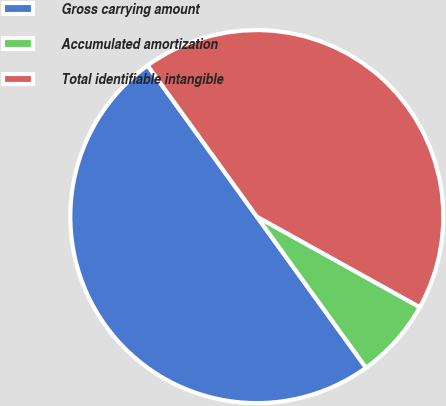Convert chart. <chart><loc_0><loc_0><loc_500><loc_500><pie_chart><fcel>Gross carrying amount<fcel>Accumulated amortization<fcel>Total identifiable intangible<nl><fcel>50.0%<fcel>6.97%<fcel>43.03%<nl></chart> 